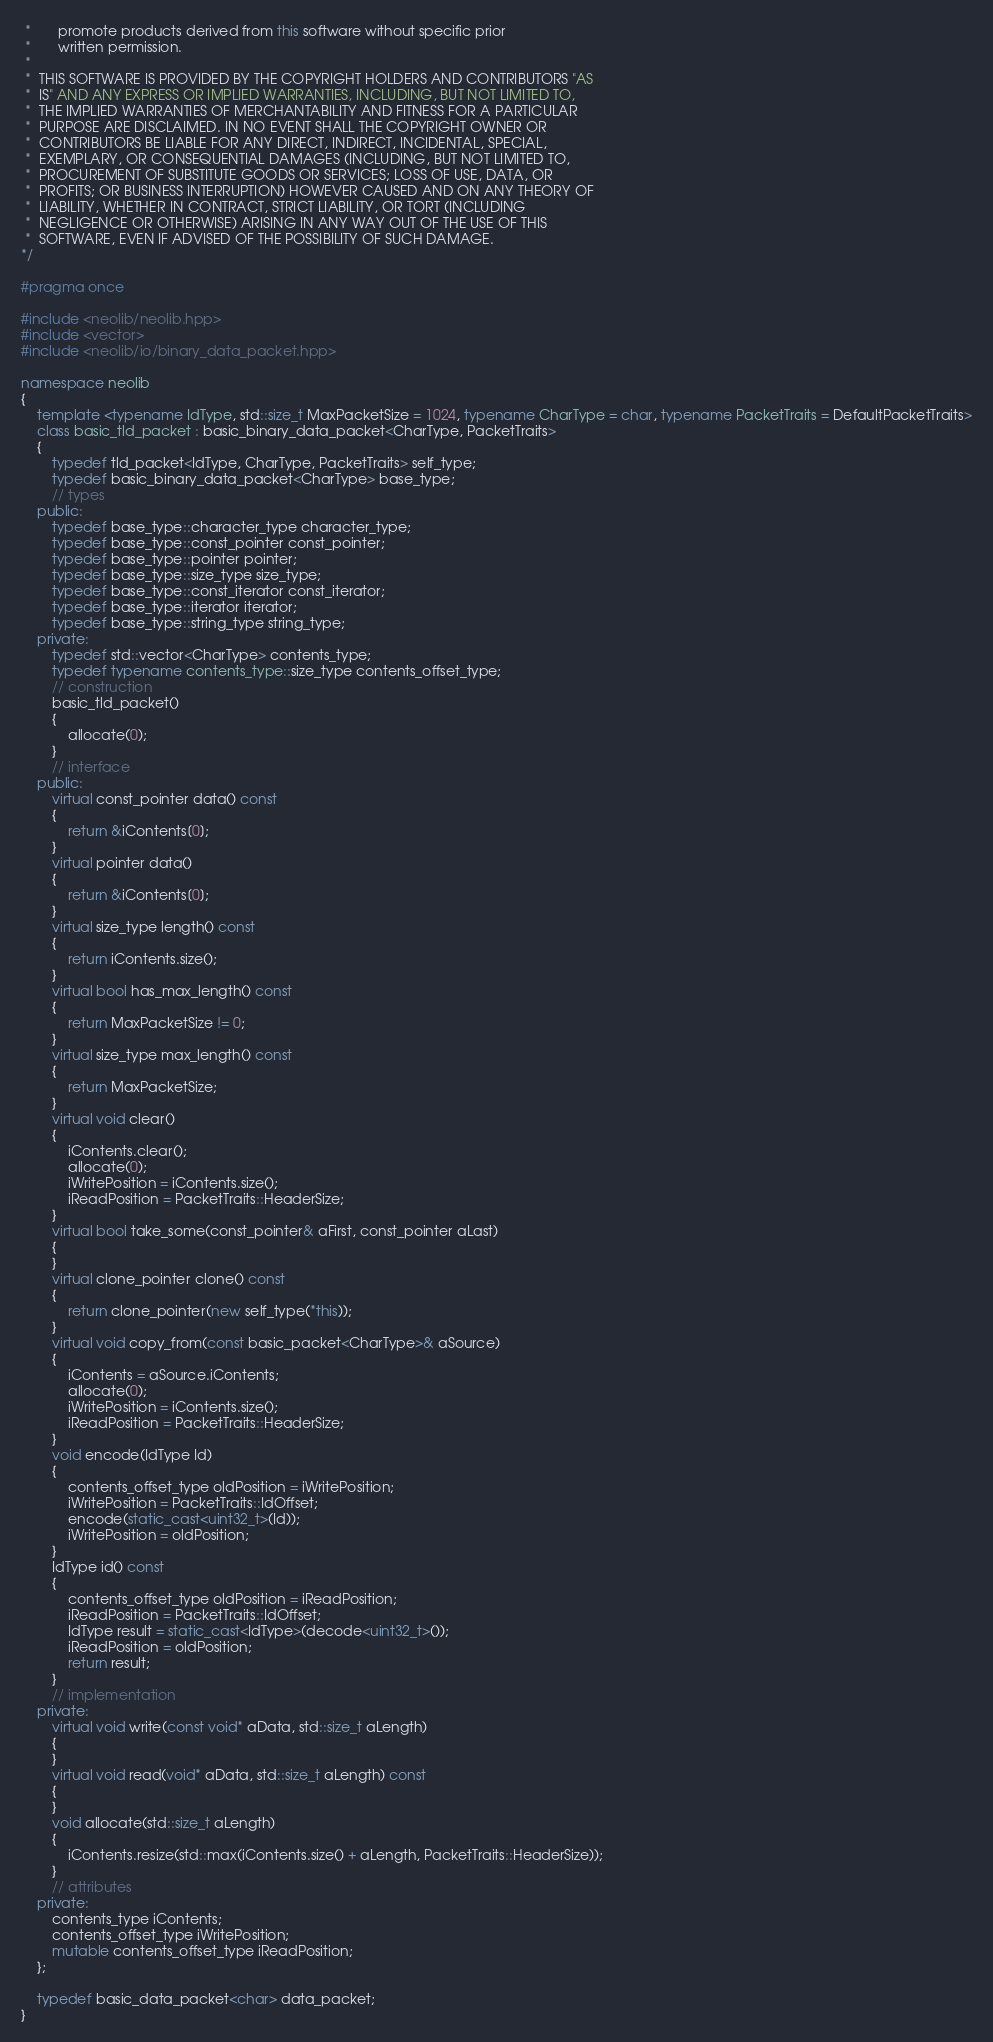<code> <loc_0><loc_0><loc_500><loc_500><_C++_> *       promote products derived from this software without specific prior
 *       written permission.
 *
 *  THIS SOFTWARE IS PROVIDED BY THE COPYRIGHT HOLDERS AND CONTRIBUTORS "AS
 *  IS" AND ANY EXPRESS OR IMPLIED WARRANTIES, INCLUDING, BUT NOT LIMITED TO,
 *  THE IMPLIED WARRANTIES OF MERCHANTABILITY AND FITNESS FOR A PARTICULAR
 *  PURPOSE ARE DISCLAIMED. IN NO EVENT SHALL THE COPYRIGHT OWNER OR
 *  CONTRIBUTORS BE LIABLE FOR ANY DIRECT, INDIRECT, INCIDENTAL, SPECIAL,
 *  EXEMPLARY, OR CONSEQUENTIAL DAMAGES (INCLUDING, BUT NOT LIMITED TO,
 *  PROCUREMENT OF SUBSTITUTE GOODS OR SERVICES; LOSS OF USE, DATA, OR
 *  PROFITS; OR BUSINESS INTERRUPTION) HOWEVER CAUSED AND ON ANY THEORY OF
 *  LIABILITY, WHETHER IN CONTRACT, STRICT LIABILITY, OR TORT (INCLUDING
 *  NEGLIGENCE OR OTHERWISE) ARISING IN ANY WAY OUT OF THE USE OF THIS
 *  SOFTWARE, EVEN IF ADVISED OF THE POSSIBILITY OF SUCH DAMAGE.
*/

#pragma once

#include <neolib/neolib.hpp>
#include <vector>
#include <neolib/io/binary_data_packet.hpp>

namespace neolib
{
    template <typename IdType, std::size_t MaxPacketSize = 1024, typename CharType = char, typename PacketTraits = DefaultPacketTraits>
    class basic_tld_packet : basic_binary_data_packet<CharType, PacketTraits>
    {
        typedef tld_packet<IdType, CharType, PacketTraits> self_type;
        typedef basic_binary_data_packet<CharType> base_type;
        // types
    public:
        typedef base_type::character_type character_type;
        typedef base_type::const_pointer const_pointer;
        typedef base_type::pointer pointer;
        typedef base_type::size_type size_type;
        typedef base_type::const_iterator const_iterator;
        typedef base_type::iterator iterator;
        typedef base_type::string_type string_type;
    private:
        typedef std::vector<CharType> contents_type;
        typedef typename contents_type::size_type contents_offset_type;
        // construction
        basic_tld_packet()
        {
            allocate(0);
        }
        // interface
    public:
        virtual const_pointer data() const
        {
            return &iContents[0];
        }
        virtual pointer data()
        {
            return &iContents[0];
        }
        virtual size_type length() const
        {
            return iContents.size();
        }
        virtual bool has_max_length() const
        {
            return MaxPacketSize != 0;
        }
        virtual size_type max_length() const
        {
            return MaxPacketSize;
        }
        virtual void clear()
        {
            iContents.clear();
            allocate(0);
            iWritePosition = iContents.size();
            iReadPosition = PacketTraits::HeaderSize;
        }
        virtual bool take_some(const_pointer& aFirst, const_pointer aLast)
        {
        }
        virtual clone_pointer clone() const
        {
            return clone_pointer(new self_type(*this));
        }
        virtual void copy_from(const basic_packet<CharType>& aSource)
        {
            iContents = aSource.iContents;
            allocate(0);
            iWritePosition = iContents.size();
            iReadPosition = PacketTraits::HeaderSize;
        }
        void encode(IdType Id)
        {
            contents_offset_type oldPosition = iWritePosition;
            iWritePosition = PacketTraits::IdOffset;
            encode(static_cast<uint32_t>(Id));
            iWritePosition = oldPosition;
        }
        IdType id() const
        {
            contents_offset_type oldPosition = iReadPosition;
            iReadPosition = PacketTraits::IdOffset;
            IdType result = static_cast<IdType>(decode<uint32_t>());
            iReadPosition = oldPosition;
            return result;
        }
        // implementation
    private:
        virtual void write(const void* aData, std::size_t aLength)
        {
        }
        virtual void read(void* aData, std::size_t aLength) const
        {
        }
        void allocate(std::size_t aLength)
        {
            iContents.resize(std::max(iContents.size() + aLength, PacketTraits::HeaderSize));
        }
        // attributes
    private:
        contents_type iContents;
        contents_offset_type iWritePosition;
        mutable contents_offset_type iReadPosition;
    };

    typedef basic_data_packet<char> data_packet;
}
</code> 